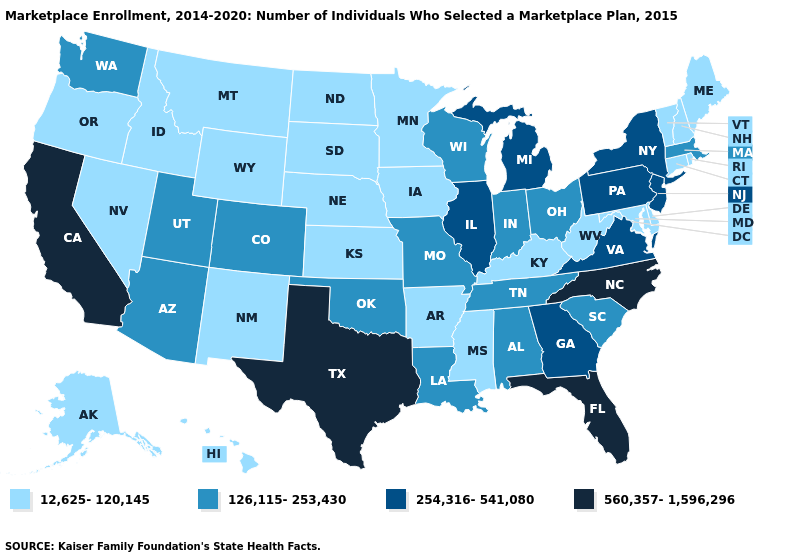Name the states that have a value in the range 12,625-120,145?
Quick response, please. Alaska, Arkansas, Connecticut, Delaware, Hawaii, Idaho, Iowa, Kansas, Kentucky, Maine, Maryland, Minnesota, Mississippi, Montana, Nebraska, Nevada, New Hampshire, New Mexico, North Dakota, Oregon, Rhode Island, South Dakota, Vermont, West Virginia, Wyoming. What is the value of Missouri?
Concise answer only. 126,115-253,430. What is the value of Wyoming?
Short answer required. 12,625-120,145. What is the value of Illinois?
Give a very brief answer. 254,316-541,080. Does the first symbol in the legend represent the smallest category?
Answer briefly. Yes. What is the value of Illinois?
Concise answer only. 254,316-541,080. What is the value of Pennsylvania?
Concise answer only. 254,316-541,080. Name the states that have a value in the range 560,357-1,596,296?
Give a very brief answer. California, Florida, North Carolina, Texas. What is the value of Hawaii?
Concise answer only. 12,625-120,145. Does Delaware have a lower value than Oregon?
Answer briefly. No. Does Michigan have a higher value than Florida?
Write a very short answer. No. Does Wyoming have the same value as South Dakota?
Keep it brief. Yes. Name the states that have a value in the range 560,357-1,596,296?
Short answer required. California, Florida, North Carolina, Texas. What is the lowest value in the Northeast?
Quick response, please. 12,625-120,145. 